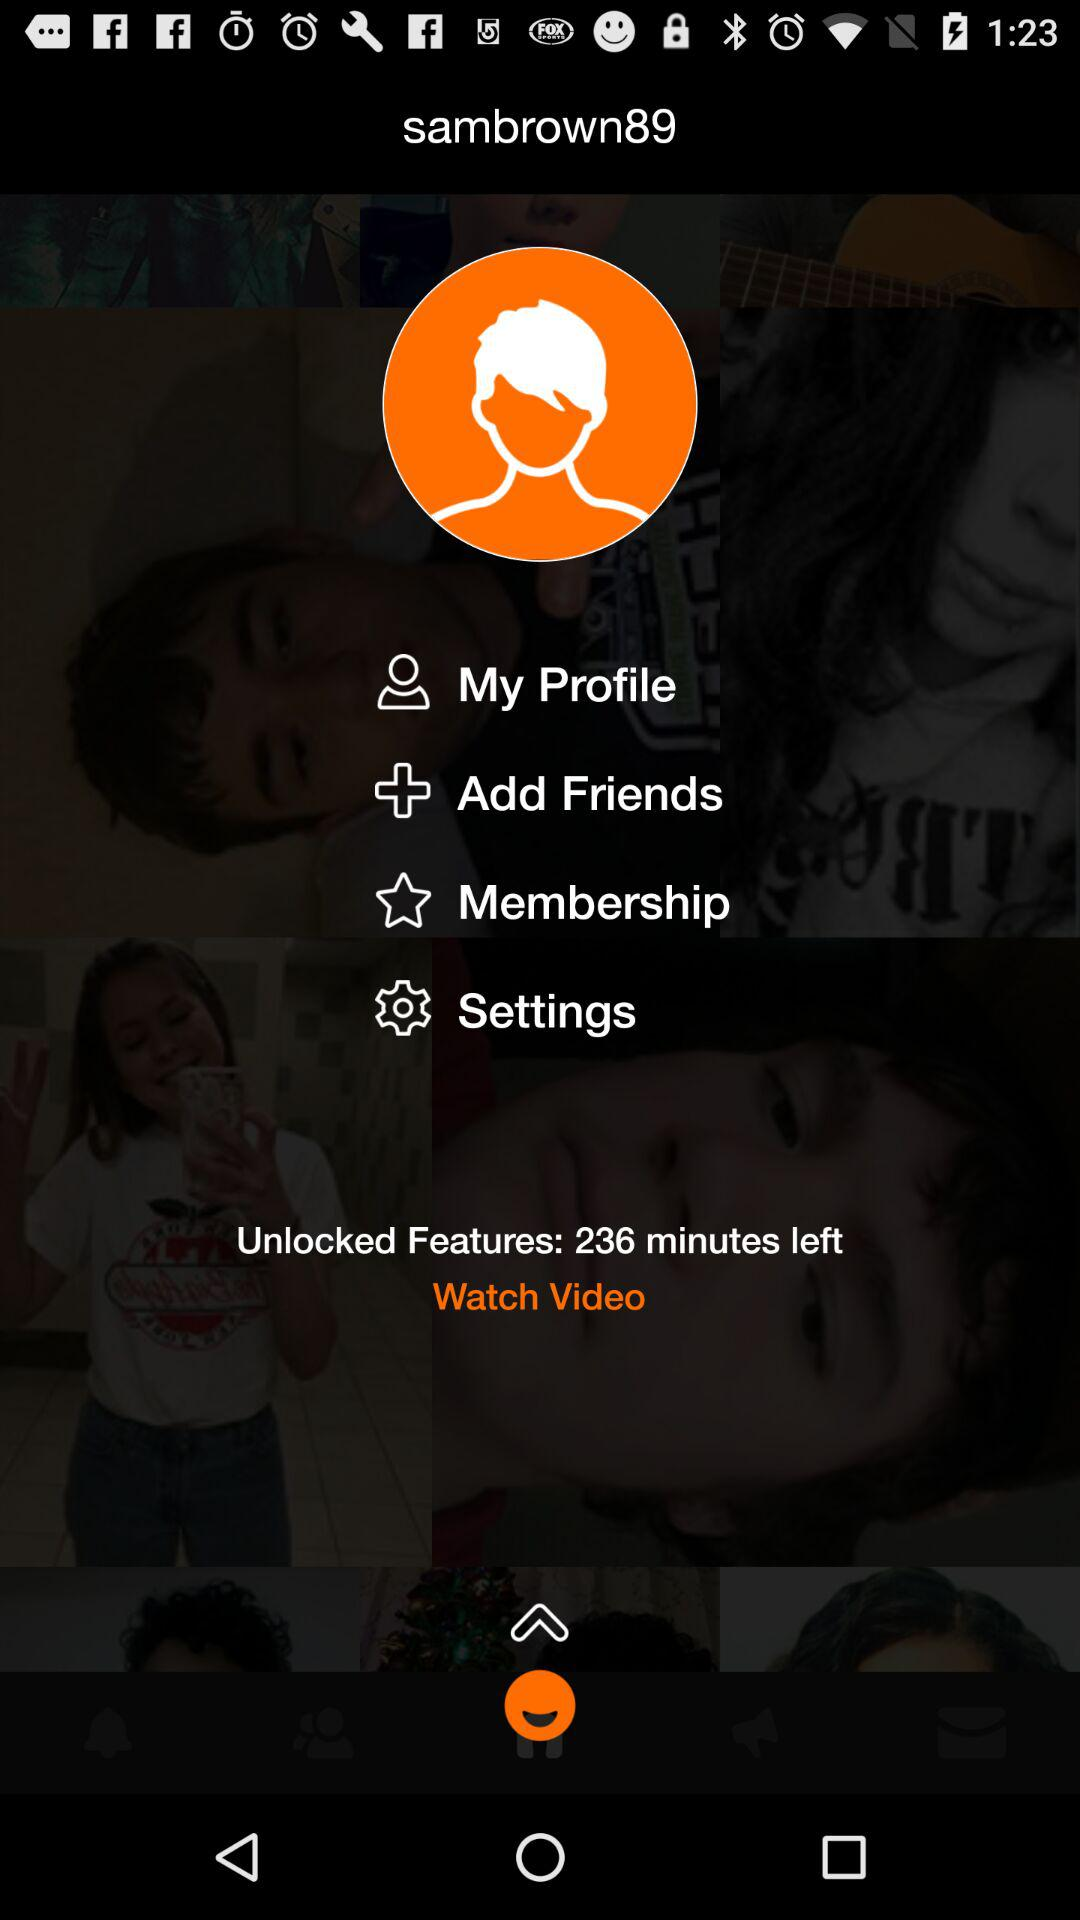How many minutes are left? There are 236 minutes left. 